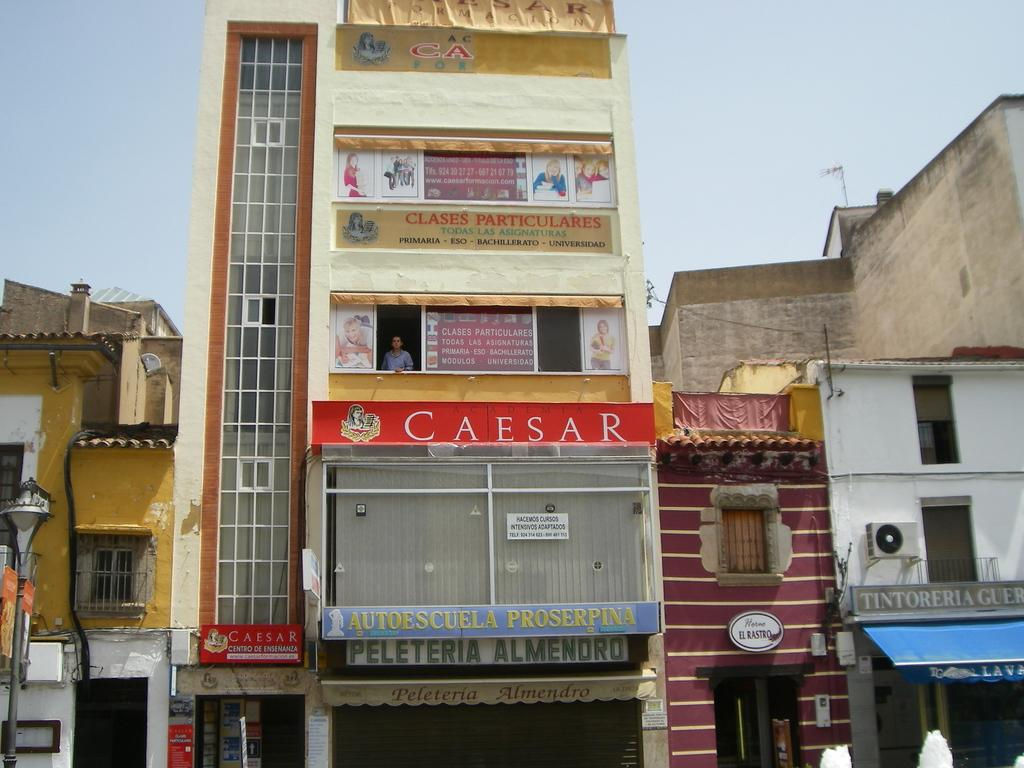What type of structures are present in the image? There are houses and a building in the image. Can you describe the central structure in the image? There is a building in the center of the image. What features can be observed on the building? The building has sign boards and windows. Is there any indication of human presence in the building? Yes, there is a person standing behind a window in the building. What type of crown is the person wearing in the image? There is no person wearing a crown in the image; the person is standing behind a window in the building. What shape is the war depicted in the image? There is no war depicted in the image; the image features houses, a building, and a person standing behind a window. 